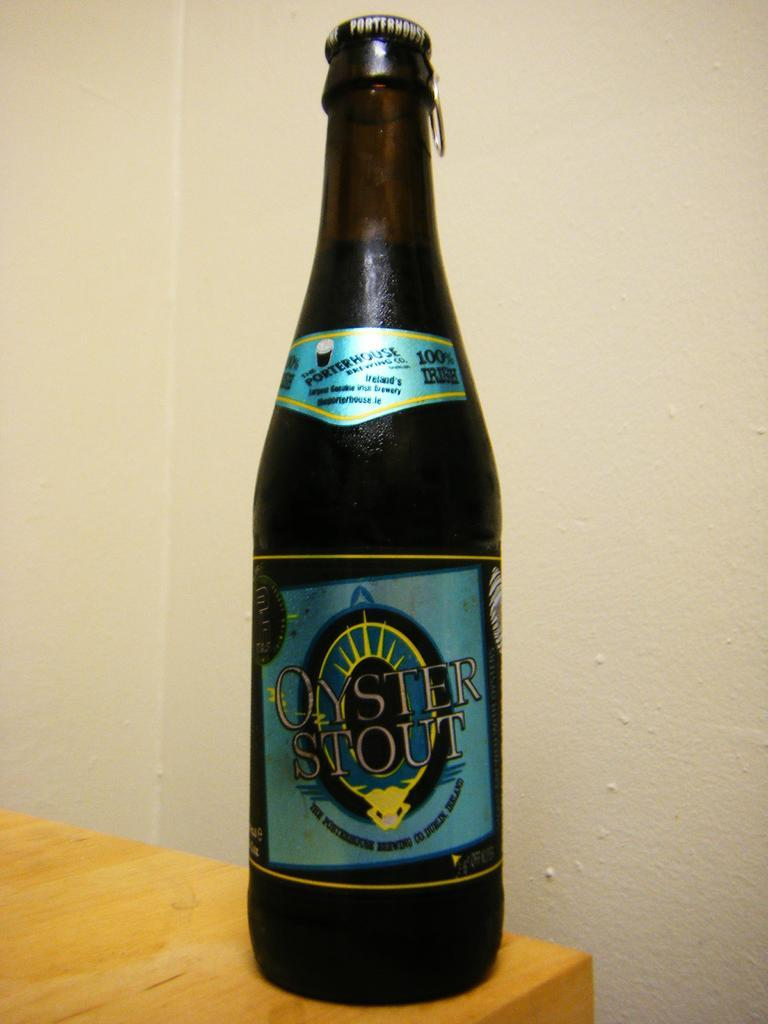Provide a one-sentence caption for the provided image. A single bottle of Oyster Stout is perched on the edge of a table. 